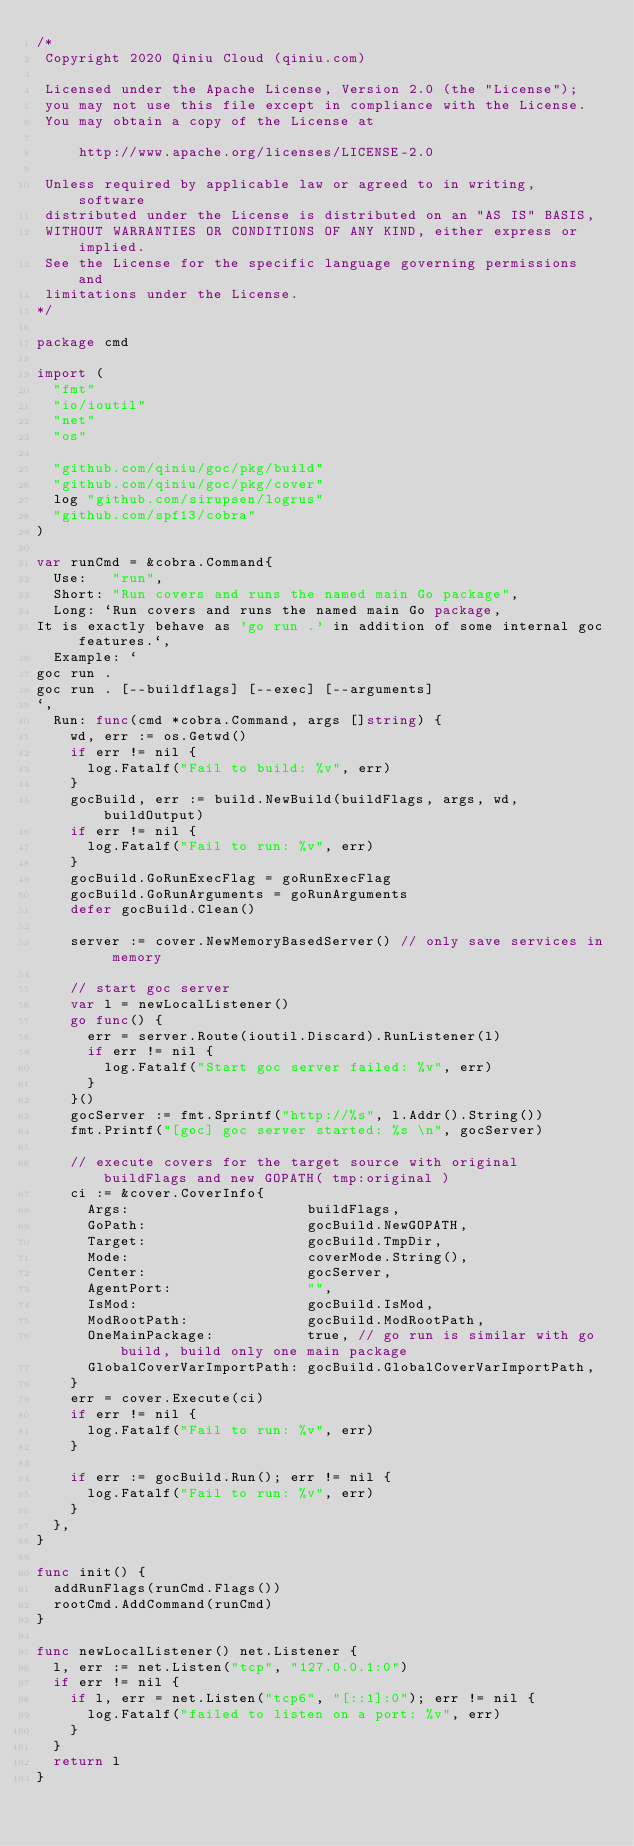Convert code to text. <code><loc_0><loc_0><loc_500><loc_500><_Go_>/*
 Copyright 2020 Qiniu Cloud (qiniu.com)

 Licensed under the Apache License, Version 2.0 (the "License");
 you may not use this file except in compliance with the License.
 You may obtain a copy of the License at

     http://www.apache.org/licenses/LICENSE-2.0

 Unless required by applicable law or agreed to in writing, software
 distributed under the License is distributed on an "AS IS" BASIS,
 WITHOUT WARRANTIES OR CONDITIONS OF ANY KIND, either express or implied.
 See the License for the specific language governing permissions and
 limitations under the License.
*/

package cmd

import (
	"fmt"
	"io/ioutil"
	"net"
	"os"

	"github.com/qiniu/goc/pkg/build"
	"github.com/qiniu/goc/pkg/cover"
	log "github.com/sirupsen/logrus"
	"github.com/spf13/cobra"
)

var runCmd = &cobra.Command{
	Use:   "run",
	Short: "Run covers and runs the named main Go package",
	Long: `Run covers and runs the named main Go package, 
It is exactly behave as 'go run .' in addition of some internal goc features.`,
	Example: `	
goc run .
goc run . [--buildflags] [--exec] [--arguments]
`,
	Run: func(cmd *cobra.Command, args []string) {
		wd, err := os.Getwd()
		if err != nil {
			log.Fatalf("Fail to build: %v", err)
		}
		gocBuild, err := build.NewBuild(buildFlags, args, wd, buildOutput)
		if err != nil {
			log.Fatalf("Fail to run: %v", err)
		}
		gocBuild.GoRunExecFlag = goRunExecFlag
		gocBuild.GoRunArguments = goRunArguments
		defer gocBuild.Clean()

		server := cover.NewMemoryBasedServer() // only save services in memory

		// start goc server
		var l = newLocalListener()
		go func() {
			err = server.Route(ioutil.Discard).RunListener(l)
			if err != nil {
				log.Fatalf("Start goc server failed: %v", err)
			}
		}()
		gocServer := fmt.Sprintf("http://%s", l.Addr().String())
		fmt.Printf("[goc] goc server started: %s \n", gocServer)

		// execute covers for the target source with original buildFlags and new GOPATH( tmp:original )
		ci := &cover.CoverInfo{
			Args:                     buildFlags,
			GoPath:                   gocBuild.NewGOPATH,
			Target:                   gocBuild.TmpDir,
			Mode:                     coverMode.String(),
			Center:                   gocServer,
			AgentPort:                "",
			IsMod:                    gocBuild.IsMod,
			ModRootPath:              gocBuild.ModRootPath,
			OneMainPackage:           true, // go run is similar with go build, build only one main package
			GlobalCoverVarImportPath: gocBuild.GlobalCoverVarImportPath,
		}
		err = cover.Execute(ci)
		if err != nil {
			log.Fatalf("Fail to run: %v", err)
		}

		if err := gocBuild.Run(); err != nil {
			log.Fatalf("Fail to run: %v", err)
		}
	},
}

func init() {
	addRunFlags(runCmd.Flags())
	rootCmd.AddCommand(runCmd)
}

func newLocalListener() net.Listener {
	l, err := net.Listen("tcp", "127.0.0.1:0")
	if err != nil {
		if l, err = net.Listen("tcp6", "[::1]:0"); err != nil {
			log.Fatalf("failed to listen on a port: %v", err)
		}
	}
	return l
}
</code> 